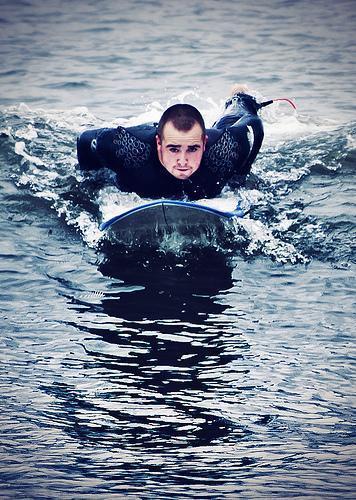How many people are in the picture?
Give a very brief answer. 1. 